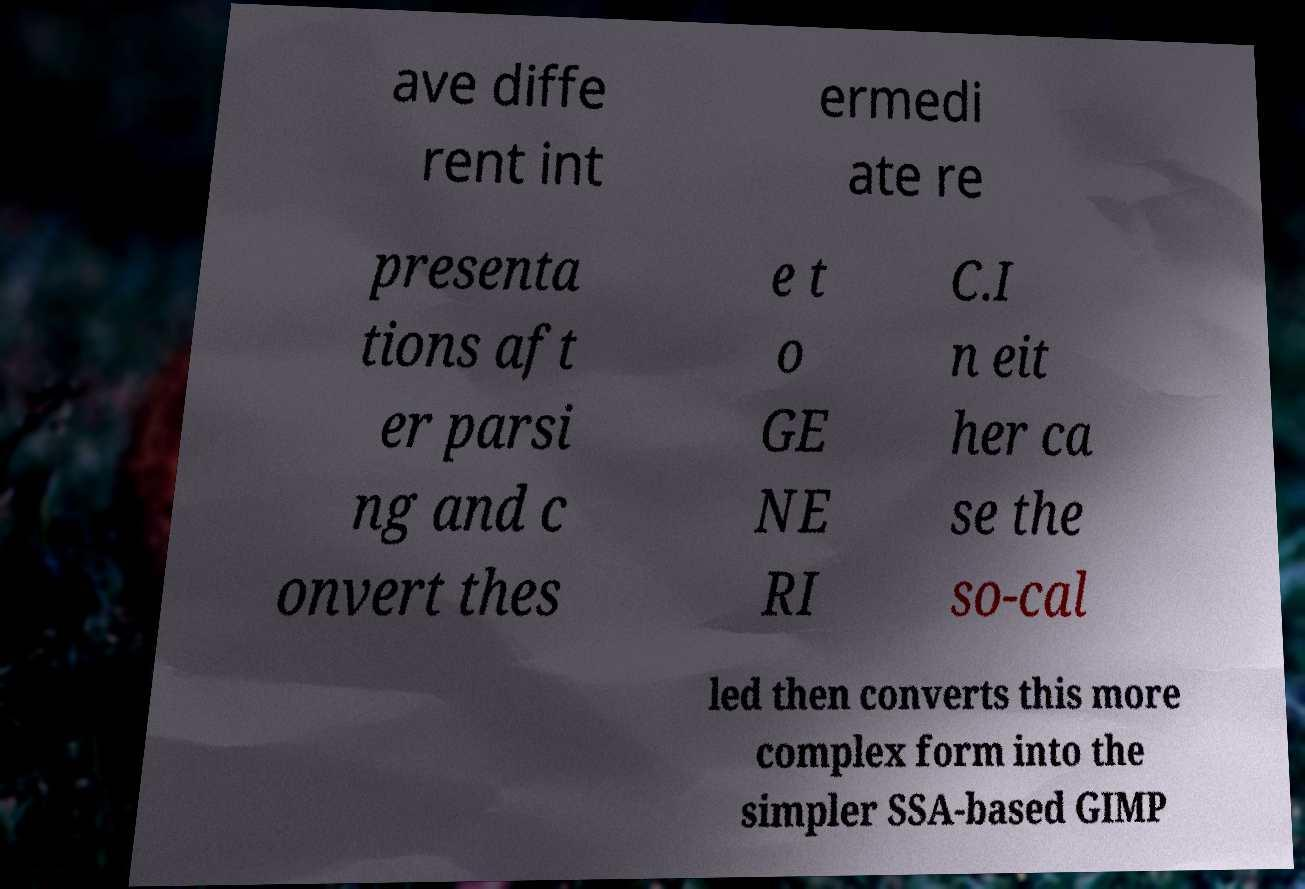Please identify and transcribe the text found in this image. ave diffe rent int ermedi ate re presenta tions aft er parsi ng and c onvert thes e t o GE NE RI C.I n eit her ca se the so-cal led then converts this more complex form into the simpler SSA-based GIMP 